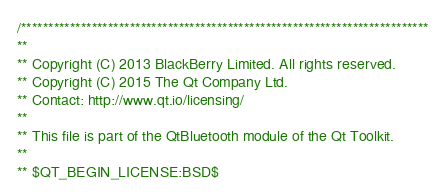Convert code to text. <code><loc_0><loc_0><loc_500><loc_500><_C++_>/***************************************************************************
**
** Copyright (C) 2013 BlackBerry Limited. All rights reserved.
** Copyright (C) 2015 The Qt Company Ltd.
** Contact: http://www.qt.io/licensing/
**
** This file is part of the QtBluetooth module of the Qt Toolkit.
**
** $QT_BEGIN_LICENSE:BSD$</code> 